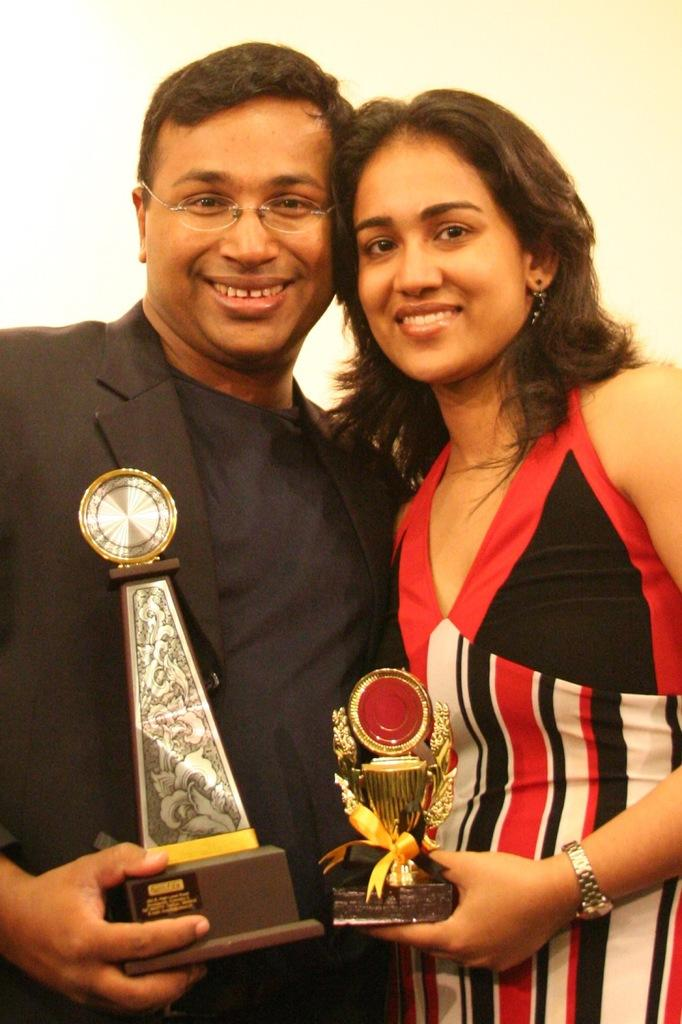Who are the people in the image? There is a man and a woman in the image. What are the man and the woman holding? Both the man and the woman are holding trophies. What expressions do the man and the woman have? The man and the woman are smiling. What type of coil is wrapped around the trophies in the image? There is no coil present in the image; the trophies are simply held by the man and the woman. 